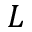Convert formula to latex. <formula><loc_0><loc_0><loc_500><loc_500>L</formula> 